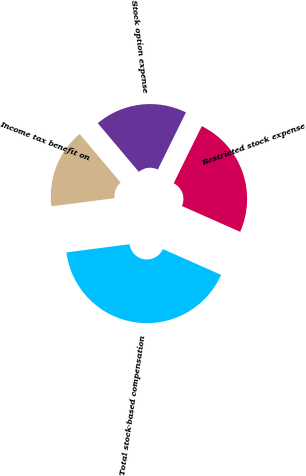Convert chart to OTSL. <chart><loc_0><loc_0><loc_500><loc_500><pie_chart><fcel>Stock option expense<fcel>Restricted stock expense<fcel>Total stock-based compensation<fcel>Income tax benefit on<nl><fcel>18.43%<fcel>24.36%<fcel>41.31%<fcel>15.89%<nl></chart> 